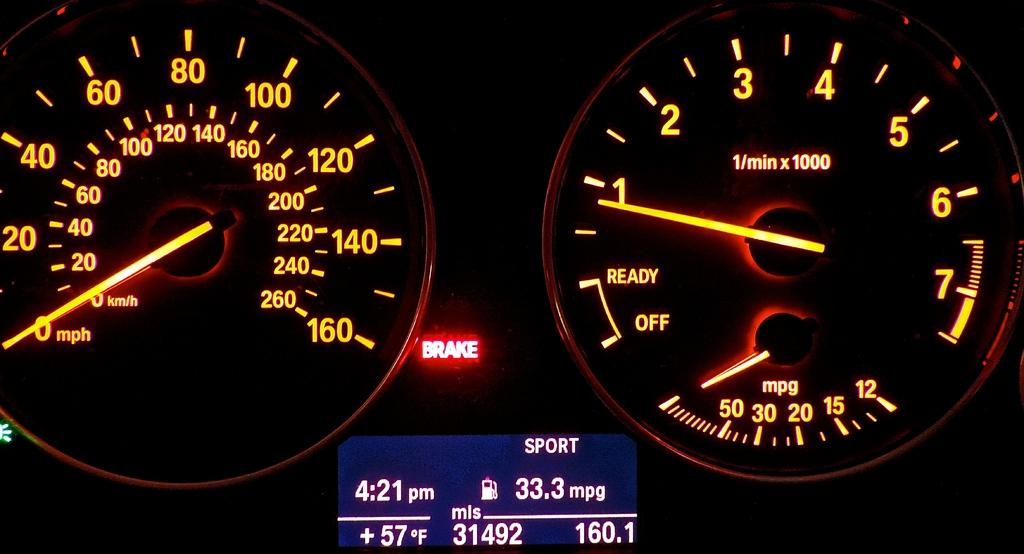<image>
Offer a succinct explanation of the picture presented. Dashboard screen which has the "BRAKE" lighting up. 